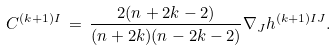Convert formula to latex. <formula><loc_0><loc_0><loc_500><loc_500>C ^ { ( k + 1 ) I } \, = \, \frac { 2 ( n + 2 k - 2 ) } { ( n + 2 k ) ( n - 2 k - 2 ) } \nabla _ { J } h ^ { ( k + 1 ) I J } .</formula> 